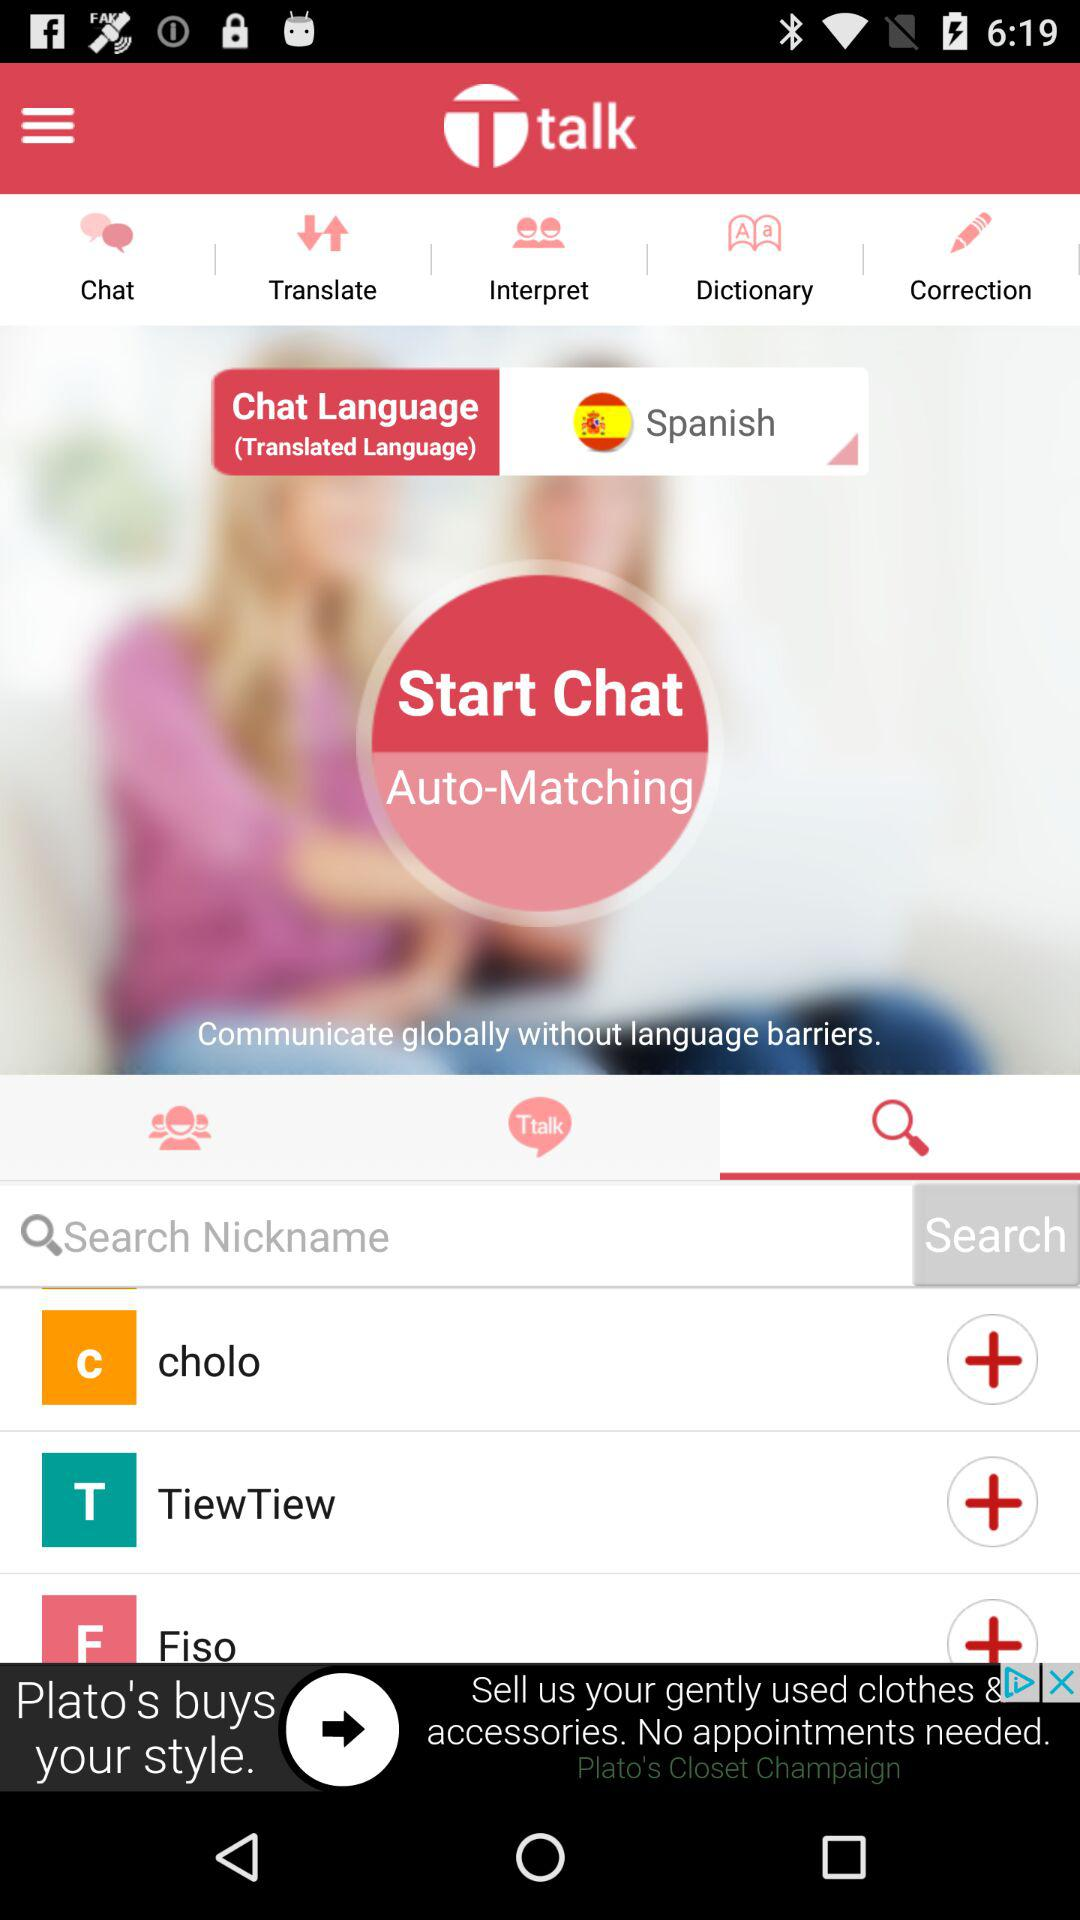What is the app name? The app name is "Ttalk". 